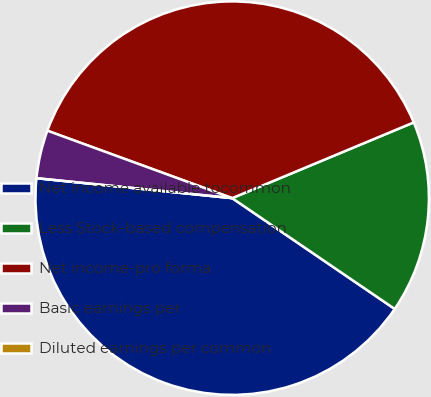<chart> <loc_0><loc_0><loc_500><loc_500><pie_chart><fcel>Net income available tocommon<fcel>Less Stock-based compensation<fcel>Net income-pro forma<fcel>Basic earnings per<fcel>Diluted earnings per common<nl><fcel>42.09%<fcel>15.81%<fcel>38.14%<fcel>3.95%<fcel>0.0%<nl></chart> 